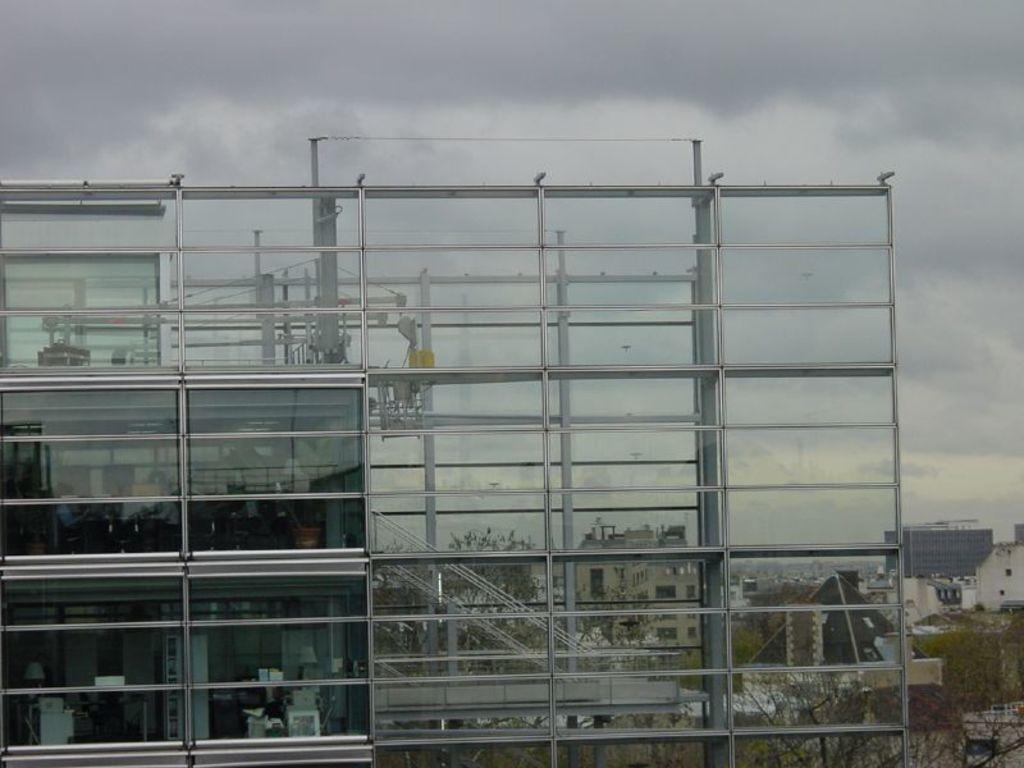How would you summarize this image in a sentence or two? In this image I can see a building which is made of glass. Through the glass windows of the building I can see few lamps, few plants, few machines and few other objects inside the building. I can see few pipes, few rods, few buildings, few trees and in the background I can see the sky. 